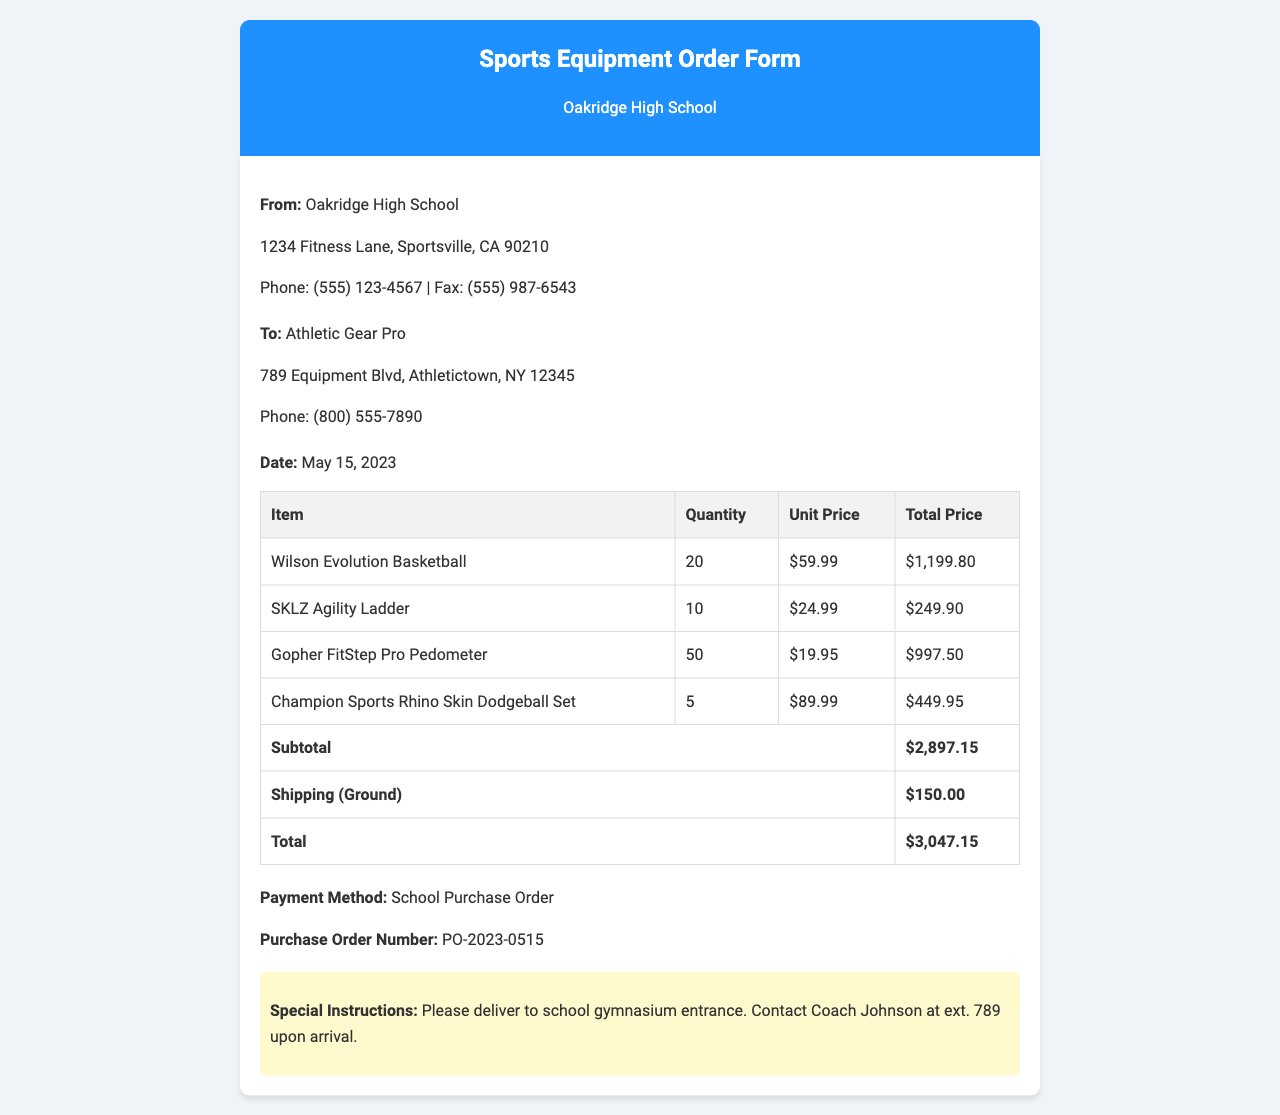What is the date of the order? The date of the order is specified in the document.
Answer: May 15, 2023 Who is the supplier of the equipment? The supplier's name is found in the "To" section of the document.
Answer: Athletic Gear Pro What is the total price of the order? The total price is stated at the bottom of the order table.
Answer: $3,047.15 How many SKLZ Agility Ladders are ordered? The quantity ordered is listed in the itemized table.
Answer: 10 What payment method is used for this order? The payment method is recorded in the payment section of the document.
Answer: School Purchase Order What is the subtotal before shipping? The subtotal is provided in the order table, prior to adding shipping costs.
Answer: $2,897.15 Where should the equipment be delivered? Special instructions indicate the delivery location.
Answer: School gymnasium entrance What is the Purchase Order number? The Purchase Order number is mentioned near the payment method.
Answer: PO-2023-0515 How many Wilson Evolution Basketballs are included in the order? The quantity for Wilson Evolution Basketballs is specified in the order.
Answer: 20 